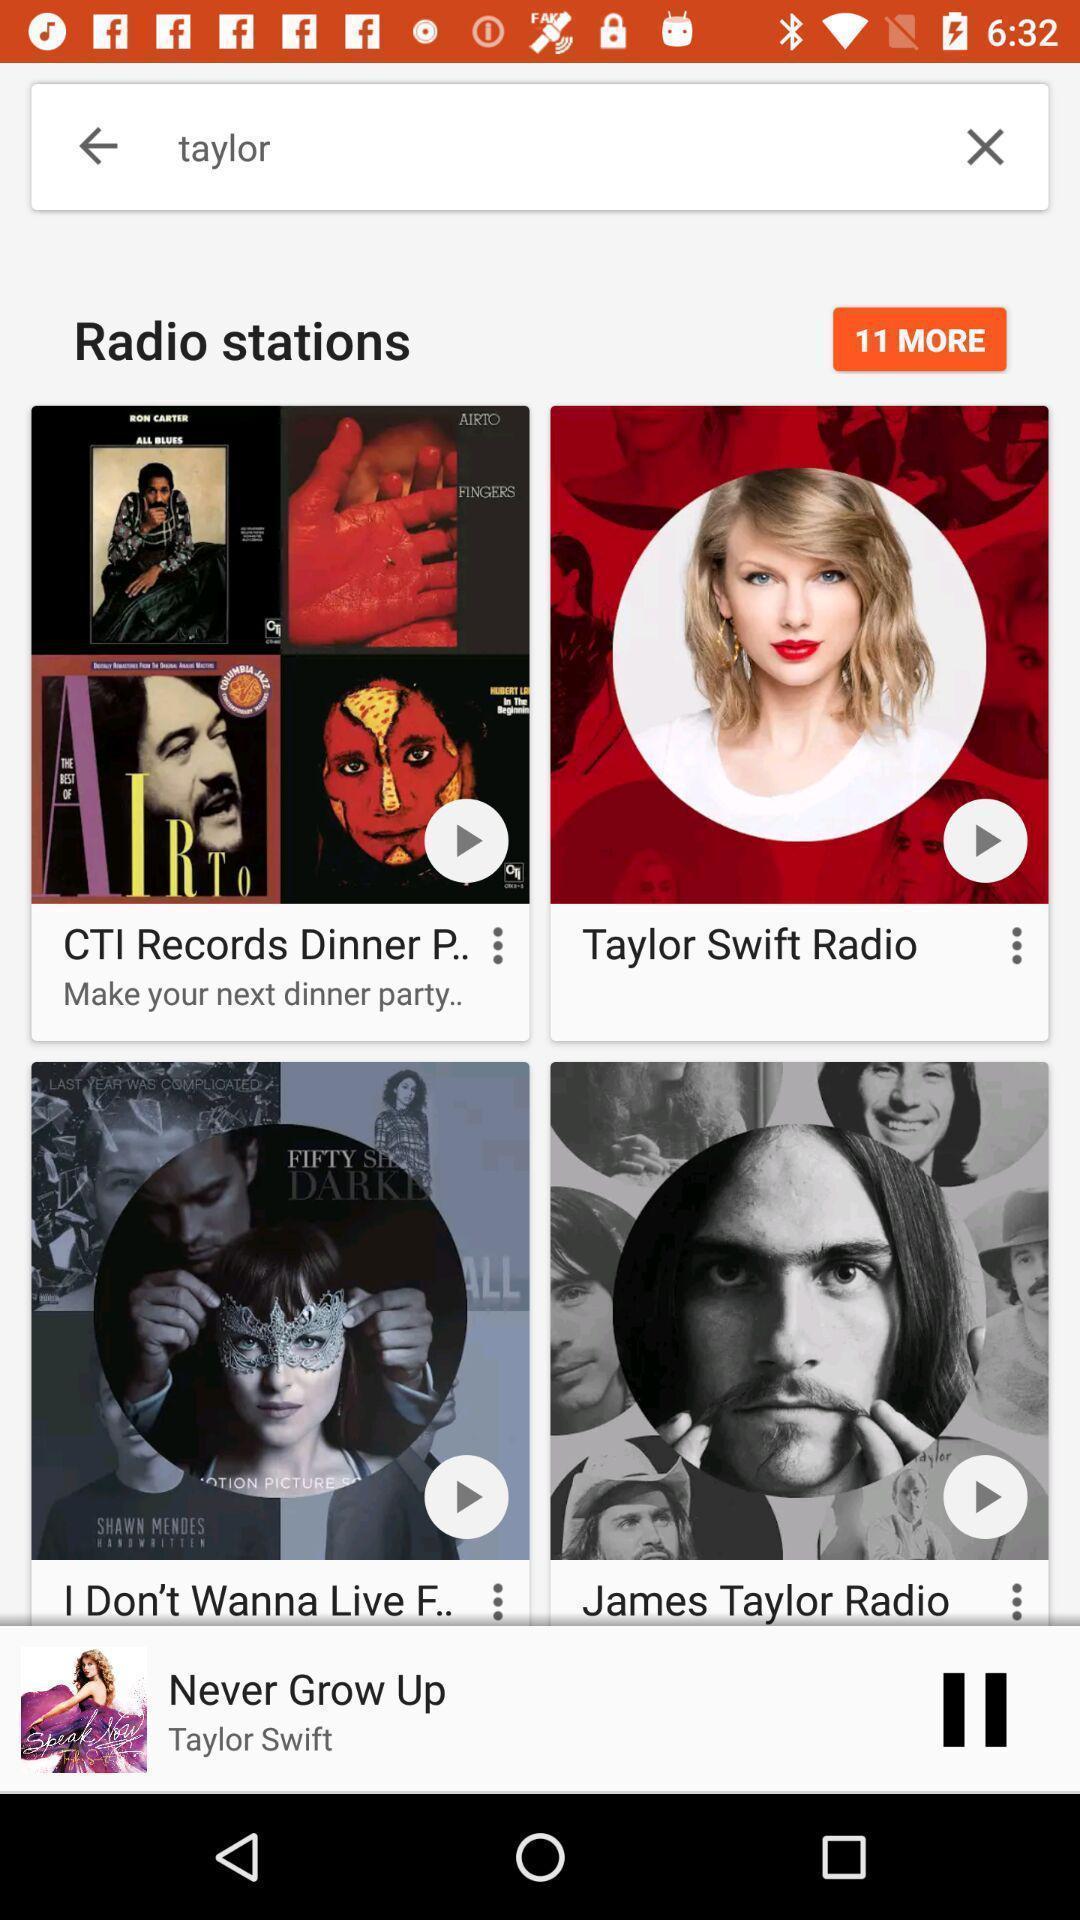What details can you identify in this image? Search page of music player app. 